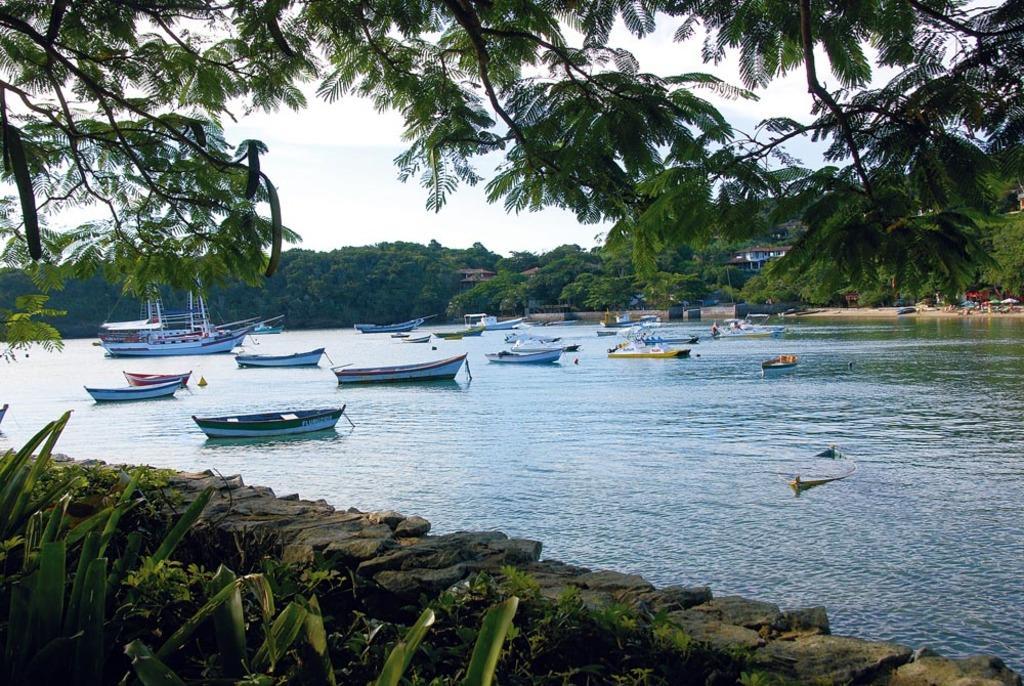In one or two sentences, can you explain what this image depicts? There are plants and stones boundary at the bottom side and there are boats and ships on the water surface. There are trees, houses, umbrellas and sky in the background area. 